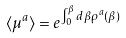<formula> <loc_0><loc_0><loc_500><loc_500>\langle \mu ^ { a } \rangle = e ^ { \int ^ { \beta } _ { 0 } d { \beta } \rho ^ { a } ( \beta ) }</formula> 